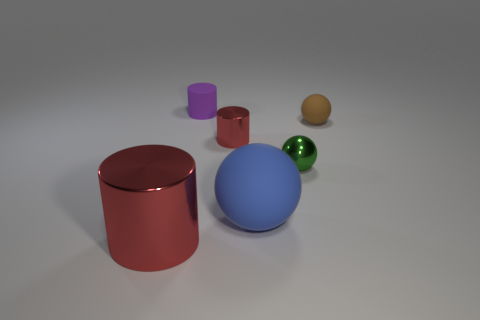Add 3 tiny purple cylinders. How many objects exist? 9 Subtract 0 cyan spheres. How many objects are left? 6 Subtract all blue objects. Subtract all purple things. How many objects are left? 4 Add 3 large rubber objects. How many large rubber objects are left? 4 Add 6 small brown matte things. How many small brown matte things exist? 7 